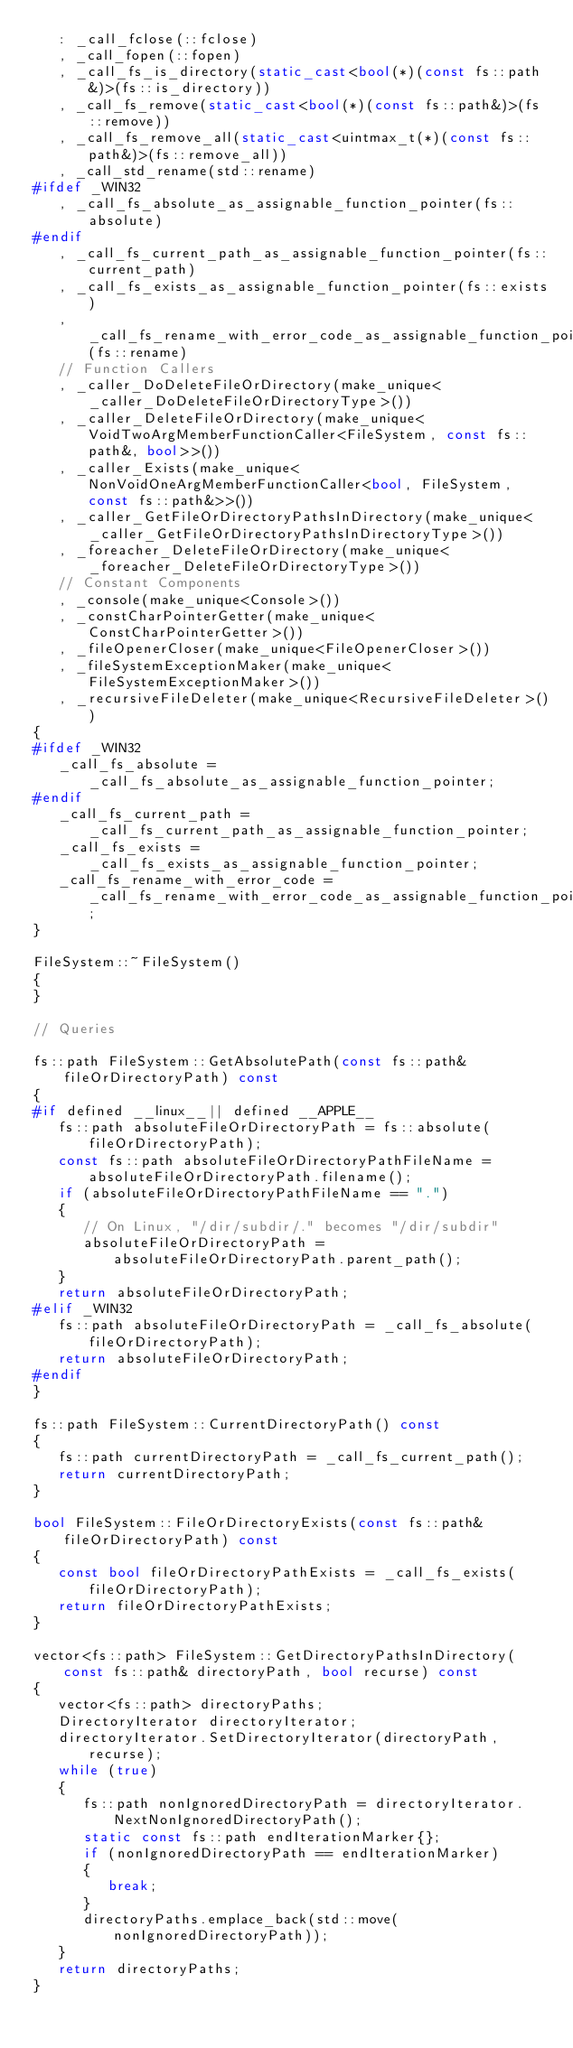Convert code to text. <code><loc_0><loc_0><loc_500><loc_500><_C++_>   : _call_fclose(::fclose)
   , _call_fopen(::fopen)
   , _call_fs_is_directory(static_cast<bool(*)(const fs::path&)>(fs::is_directory))
   , _call_fs_remove(static_cast<bool(*)(const fs::path&)>(fs::remove))
   , _call_fs_remove_all(static_cast<uintmax_t(*)(const fs::path&)>(fs::remove_all))
   , _call_std_rename(std::rename)
#ifdef _WIN32
   , _call_fs_absolute_as_assignable_function_pointer(fs::absolute)
#endif
   , _call_fs_current_path_as_assignable_function_pointer(fs::current_path)
   , _call_fs_exists_as_assignable_function_pointer(fs::exists)
   , _call_fs_rename_with_error_code_as_assignable_function_pointer(fs::rename)
   // Function Callers
   , _caller_DoDeleteFileOrDirectory(make_unique<_caller_DoDeleteFileOrDirectoryType>())
   , _caller_DeleteFileOrDirectory(make_unique<VoidTwoArgMemberFunctionCaller<FileSystem, const fs::path&, bool>>())
   , _caller_Exists(make_unique<NonVoidOneArgMemberFunctionCaller<bool, FileSystem, const fs::path&>>())
   , _caller_GetFileOrDirectoryPathsInDirectory(make_unique<_caller_GetFileOrDirectoryPathsInDirectoryType>())
   , _foreacher_DeleteFileOrDirectory(make_unique<_foreacher_DeleteFileOrDirectoryType>())
   // Constant Components
   , _console(make_unique<Console>())
   , _constCharPointerGetter(make_unique<ConstCharPointerGetter>())
   , _fileOpenerCloser(make_unique<FileOpenerCloser>())
   , _fileSystemExceptionMaker(make_unique<FileSystemExceptionMaker>())
   , _recursiveFileDeleter(make_unique<RecursiveFileDeleter>())
{
#ifdef _WIN32
   _call_fs_absolute = _call_fs_absolute_as_assignable_function_pointer;
#endif
   _call_fs_current_path = _call_fs_current_path_as_assignable_function_pointer;
   _call_fs_exists = _call_fs_exists_as_assignable_function_pointer;
   _call_fs_rename_with_error_code = _call_fs_rename_with_error_code_as_assignable_function_pointer;
}

FileSystem::~FileSystem()
{
}

// Queries

fs::path FileSystem::GetAbsolutePath(const fs::path& fileOrDirectoryPath) const
{
#if defined __linux__|| defined __APPLE__
   fs::path absoluteFileOrDirectoryPath = fs::absolute(fileOrDirectoryPath);
   const fs::path absoluteFileOrDirectoryPathFileName = absoluteFileOrDirectoryPath.filename();
   if (absoluteFileOrDirectoryPathFileName == ".")
   {
      // On Linux, "/dir/subdir/." becomes "/dir/subdir"
      absoluteFileOrDirectoryPath = absoluteFileOrDirectoryPath.parent_path();
   }
   return absoluteFileOrDirectoryPath;
#elif _WIN32
   fs::path absoluteFileOrDirectoryPath = _call_fs_absolute(fileOrDirectoryPath);
   return absoluteFileOrDirectoryPath;
#endif
}

fs::path FileSystem::CurrentDirectoryPath() const
{
   fs::path currentDirectoryPath = _call_fs_current_path();
   return currentDirectoryPath;
}

bool FileSystem::FileOrDirectoryExists(const fs::path& fileOrDirectoryPath) const
{
   const bool fileOrDirectoryPathExists = _call_fs_exists(fileOrDirectoryPath);
   return fileOrDirectoryPathExists;
}

vector<fs::path> FileSystem::GetDirectoryPathsInDirectory(const fs::path& directoryPath, bool recurse) const
{
   vector<fs::path> directoryPaths;
   DirectoryIterator directoryIterator;
   directoryIterator.SetDirectoryIterator(directoryPath, recurse);
   while (true)
   {
      fs::path nonIgnoredDirectoryPath = directoryIterator.NextNonIgnoredDirectoryPath();
      static const fs::path endIterationMarker{};
      if (nonIgnoredDirectoryPath == endIterationMarker)
      {
         break;
      }
      directoryPaths.emplace_back(std::move(nonIgnoredDirectoryPath));
   }
   return directoryPaths;
}
</code> 